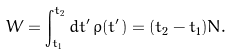Convert formula to latex. <formula><loc_0><loc_0><loc_500><loc_500>W = \int _ { t _ { 1 } } ^ { t _ { 2 } } d t ^ { \prime } \, \rho ( t ^ { \prime } ) = ( t _ { 2 } - t _ { 1 } ) N .</formula> 